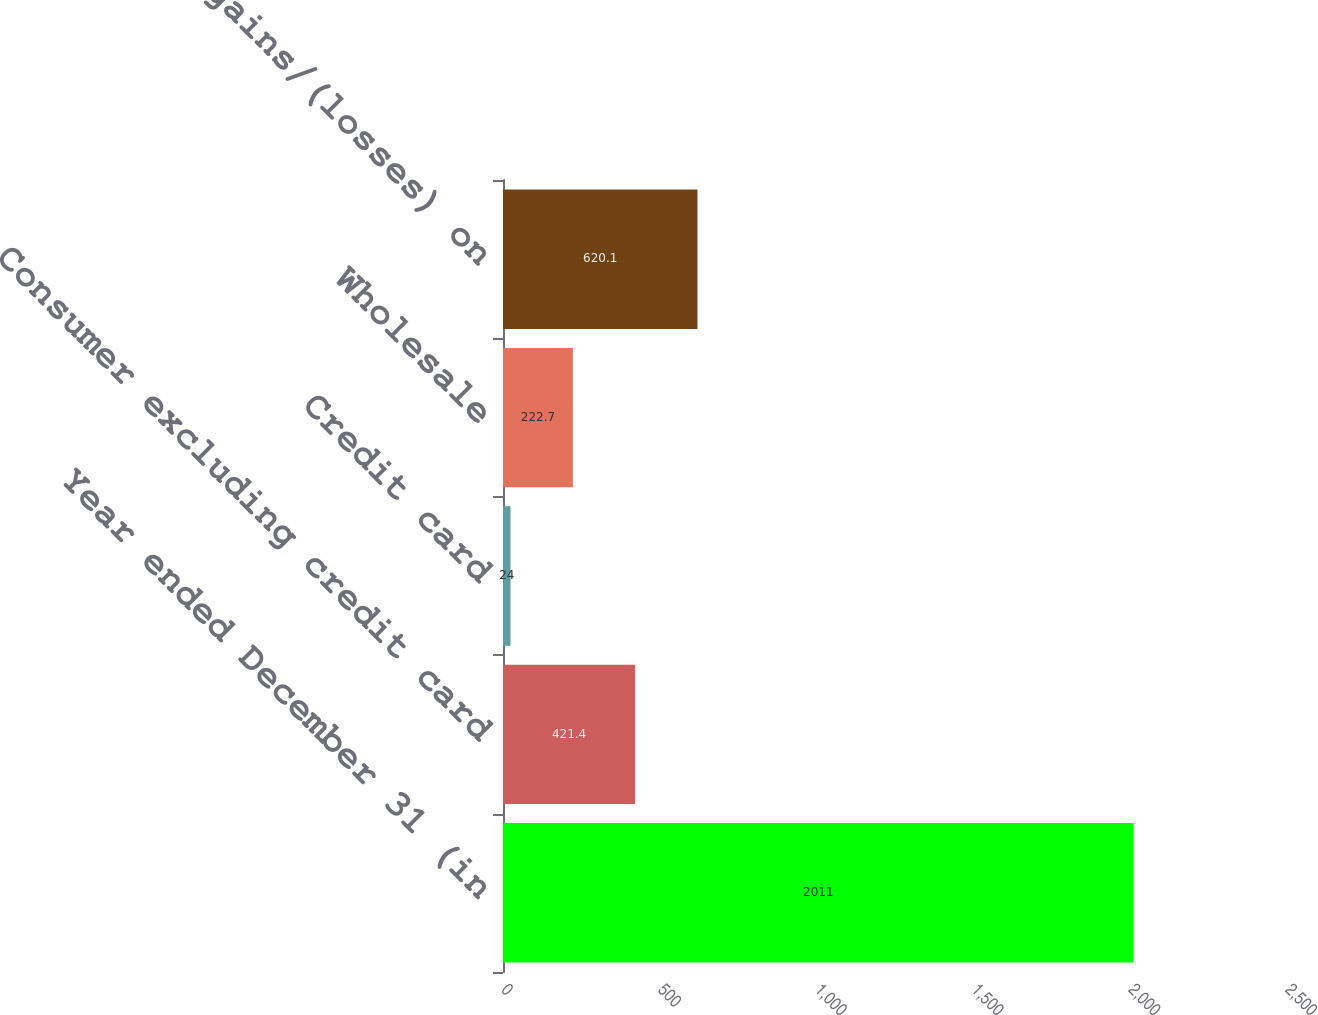Convert chart to OTSL. <chart><loc_0><loc_0><loc_500><loc_500><bar_chart><fcel>Year ended December 31 (in<fcel>Consumer excluding credit card<fcel>Credit card<fcel>Wholesale<fcel>Total net gains/(losses) on<nl><fcel>2011<fcel>421.4<fcel>24<fcel>222.7<fcel>620.1<nl></chart> 